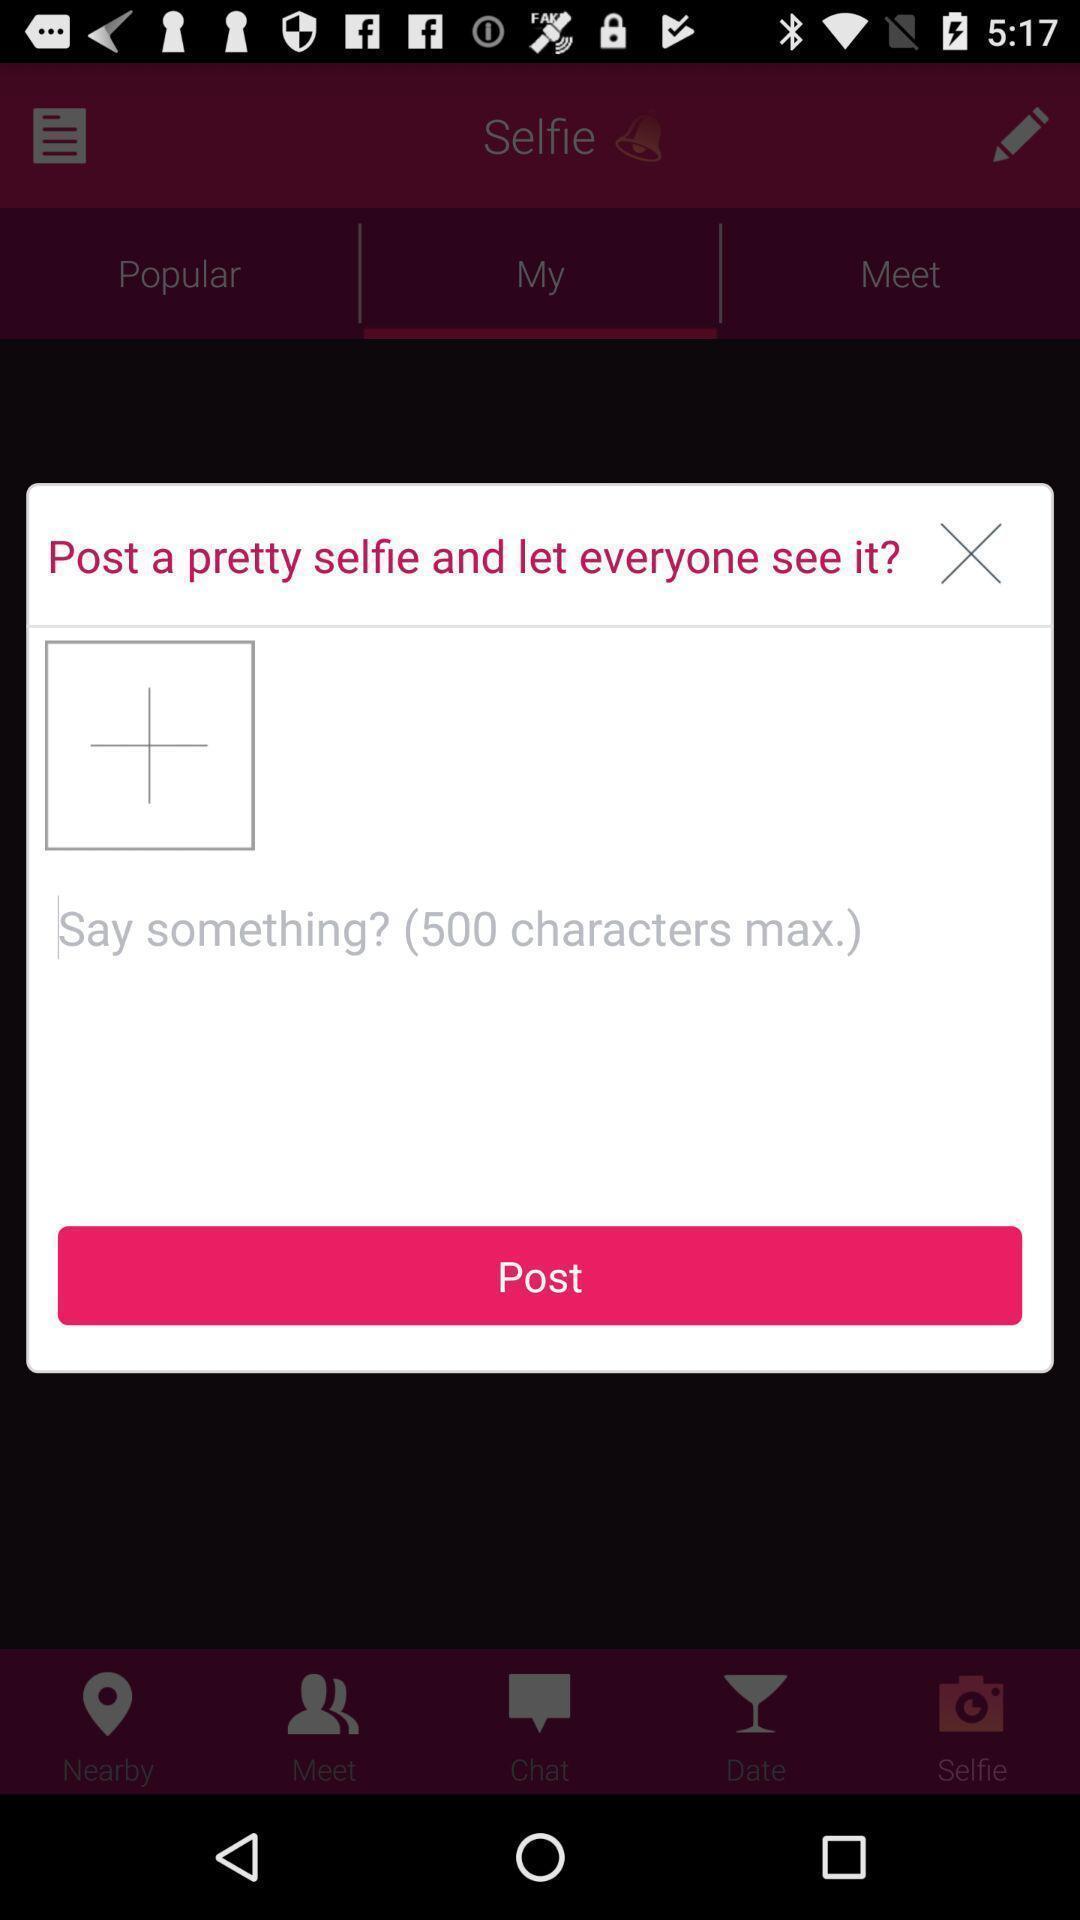Give me a narrative description of this picture. Popup page for posting a selfie for a dating app. 